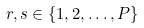<formula> <loc_0><loc_0><loc_500><loc_500>r , s \in \left \{ 1 , 2 , \dots , P \right \}</formula> 